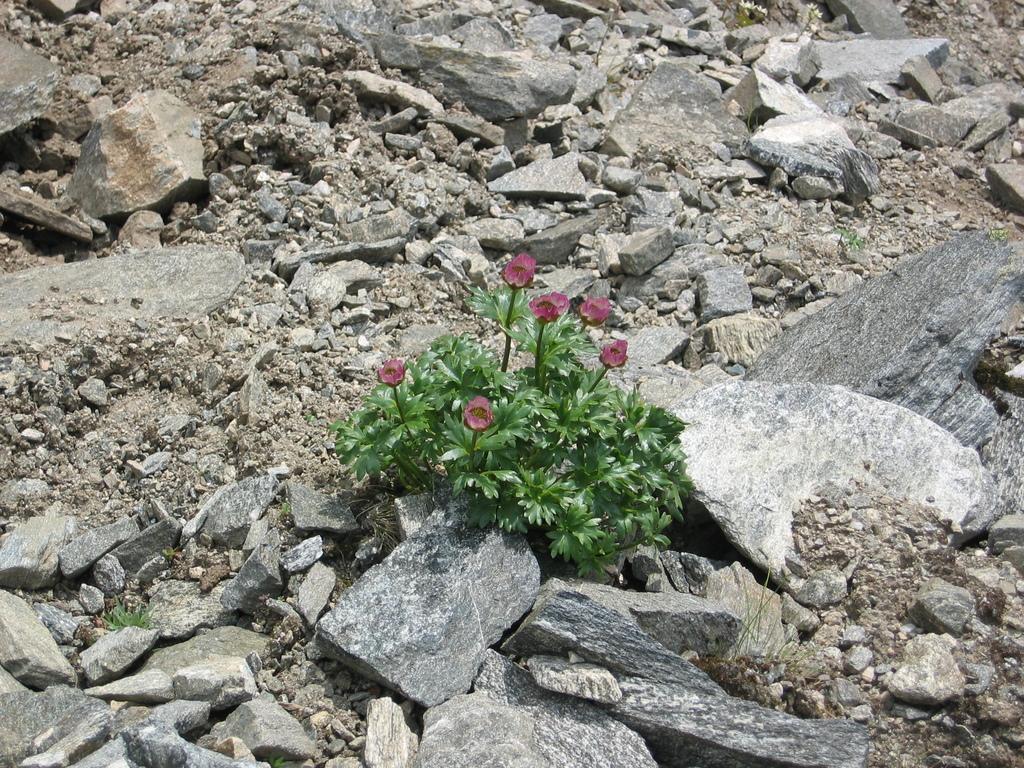Could you give a brief overview of what you see in this image? In this image in the middle, there are plants and flowers. In the background there are stones and land. 